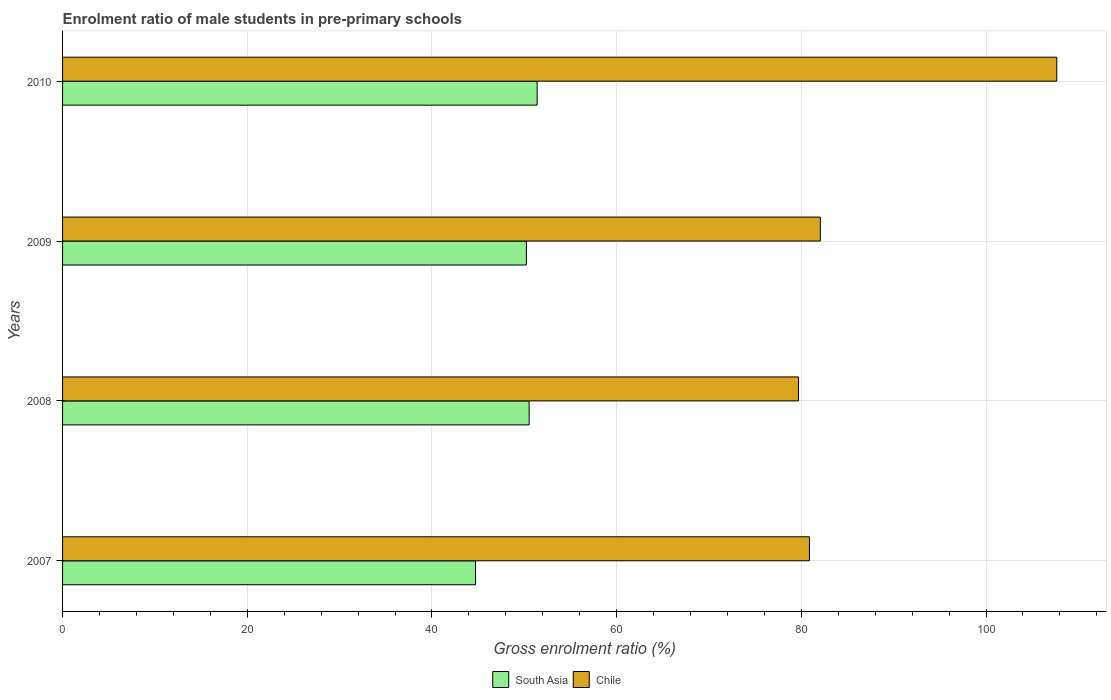How many different coloured bars are there?
Keep it short and to the point. 2. How many groups of bars are there?
Provide a short and direct response. 4. How many bars are there on the 3rd tick from the top?
Provide a short and direct response. 2. How many bars are there on the 2nd tick from the bottom?
Offer a terse response. 2. In how many cases, is the number of bars for a given year not equal to the number of legend labels?
Your answer should be compact. 0. What is the enrolment ratio of male students in pre-primary schools in South Asia in 2010?
Provide a succinct answer. 51.39. Across all years, what is the maximum enrolment ratio of male students in pre-primary schools in South Asia?
Make the answer very short. 51.39. Across all years, what is the minimum enrolment ratio of male students in pre-primary schools in South Asia?
Offer a very short reply. 44.72. In which year was the enrolment ratio of male students in pre-primary schools in South Asia minimum?
Offer a very short reply. 2007. What is the total enrolment ratio of male students in pre-primary schools in South Asia in the graph?
Provide a succinct answer. 196.86. What is the difference between the enrolment ratio of male students in pre-primary schools in South Asia in 2007 and that in 2008?
Your answer should be compact. -5.81. What is the difference between the enrolment ratio of male students in pre-primary schools in Chile in 2010 and the enrolment ratio of male students in pre-primary schools in South Asia in 2007?
Provide a short and direct response. 62.94. What is the average enrolment ratio of male students in pre-primary schools in Chile per year?
Provide a succinct answer. 87.57. In the year 2008, what is the difference between the enrolment ratio of male students in pre-primary schools in South Asia and enrolment ratio of male students in pre-primary schools in Chile?
Make the answer very short. -29.17. In how many years, is the enrolment ratio of male students in pre-primary schools in South Asia greater than 64 %?
Make the answer very short. 0. What is the ratio of the enrolment ratio of male students in pre-primary schools in Chile in 2007 to that in 2008?
Your response must be concise. 1.01. What is the difference between the highest and the second highest enrolment ratio of male students in pre-primary schools in Chile?
Your response must be concise. 25.61. What is the difference between the highest and the lowest enrolment ratio of male students in pre-primary schools in Chile?
Your response must be concise. 27.97. In how many years, is the enrolment ratio of male students in pre-primary schools in Chile greater than the average enrolment ratio of male students in pre-primary schools in Chile taken over all years?
Give a very brief answer. 1. Is the sum of the enrolment ratio of male students in pre-primary schools in South Asia in 2008 and 2010 greater than the maximum enrolment ratio of male students in pre-primary schools in Chile across all years?
Offer a very short reply. No. What does the 1st bar from the top in 2008 represents?
Offer a terse response. Chile. How many bars are there?
Your answer should be very brief. 8. Are all the bars in the graph horizontal?
Offer a very short reply. Yes. How many years are there in the graph?
Your answer should be compact. 4. Are the values on the major ticks of X-axis written in scientific E-notation?
Ensure brevity in your answer.  No. Where does the legend appear in the graph?
Provide a short and direct response. Bottom center. How many legend labels are there?
Your response must be concise. 2. How are the legend labels stacked?
Your answer should be very brief. Horizontal. What is the title of the graph?
Give a very brief answer. Enrolment ratio of male students in pre-primary schools. Does "Slovenia" appear as one of the legend labels in the graph?
Make the answer very short. No. What is the Gross enrolment ratio (%) in South Asia in 2007?
Offer a very short reply. 44.72. What is the Gross enrolment ratio (%) of Chile in 2007?
Provide a succinct answer. 80.88. What is the Gross enrolment ratio (%) in South Asia in 2008?
Provide a succinct answer. 50.52. What is the Gross enrolment ratio (%) of Chile in 2008?
Provide a short and direct response. 79.69. What is the Gross enrolment ratio (%) of South Asia in 2009?
Provide a succinct answer. 50.23. What is the Gross enrolment ratio (%) in Chile in 2009?
Make the answer very short. 82.05. What is the Gross enrolment ratio (%) in South Asia in 2010?
Provide a short and direct response. 51.39. What is the Gross enrolment ratio (%) of Chile in 2010?
Give a very brief answer. 107.66. Across all years, what is the maximum Gross enrolment ratio (%) in South Asia?
Ensure brevity in your answer.  51.39. Across all years, what is the maximum Gross enrolment ratio (%) of Chile?
Provide a succinct answer. 107.66. Across all years, what is the minimum Gross enrolment ratio (%) of South Asia?
Offer a terse response. 44.72. Across all years, what is the minimum Gross enrolment ratio (%) of Chile?
Offer a very short reply. 79.69. What is the total Gross enrolment ratio (%) of South Asia in the graph?
Your answer should be compact. 196.86. What is the total Gross enrolment ratio (%) in Chile in the graph?
Keep it short and to the point. 350.28. What is the difference between the Gross enrolment ratio (%) in South Asia in 2007 and that in 2008?
Provide a short and direct response. -5.81. What is the difference between the Gross enrolment ratio (%) in Chile in 2007 and that in 2008?
Your answer should be compact. 1.19. What is the difference between the Gross enrolment ratio (%) in South Asia in 2007 and that in 2009?
Offer a terse response. -5.51. What is the difference between the Gross enrolment ratio (%) of Chile in 2007 and that in 2009?
Offer a very short reply. -1.18. What is the difference between the Gross enrolment ratio (%) in South Asia in 2007 and that in 2010?
Make the answer very short. -6.67. What is the difference between the Gross enrolment ratio (%) in Chile in 2007 and that in 2010?
Keep it short and to the point. -26.78. What is the difference between the Gross enrolment ratio (%) of South Asia in 2008 and that in 2009?
Provide a short and direct response. 0.3. What is the difference between the Gross enrolment ratio (%) in Chile in 2008 and that in 2009?
Make the answer very short. -2.36. What is the difference between the Gross enrolment ratio (%) of South Asia in 2008 and that in 2010?
Your answer should be very brief. -0.86. What is the difference between the Gross enrolment ratio (%) in Chile in 2008 and that in 2010?
Your answer should be very brief. -27.97. What is the difference between the Gross enrolment ratio (%) of South Asia in 2009 and that in 2010?
Keep it short and to the point. -1.16. What is the difference between the Gross enrolment ratio (%) in Chile in 2009 and that in 2010?
Make the answer very short. -25.61. What is the difference between the Gross enrolment ratio (%) of South Asia in 2007 and the Gross enrolment ratio (%) of Chile in 2008?
Keep it short and to the point. -34.97. What is the difference between the Gross enrolment ratio (%) in South Asia in 2007 and the Gross enrolment ratio (%) in Chile in 2009?
Your answer should be very brief. -37.34. What is the difference between the Gross enrolment ratio (%) of South Asia in 2007 and the Gross enrolment ratio (%) of Chile in 2010?
Give a very brief answer. -62.94. What is the difference between the Gross enrolment ratio (%) in South Asia in 2008 and the Gross enrolment ratio (%) in Chile in 2009?
Keep it short and to the point. -31.53. What is the difference between the Gross enrolment ratio (%) of South Asia in 2008 and the Gross enrolment ratio (%) of Chile in 2010?
Provide a succinct answer. -57.14. What is the difference between the Gross enrolment ratio (%) in South Asia in 2009 and the Gross enrolment ratio (%) in Chile in 2010?
Ensure brevity in your answer.  -57.43. What is the average Gross enrolment ratio (%) of South Asia per year?
Your answer should be compact. 49.21. What is the average Gross enrolment ratio (%) in Chile per year?
Your response must be concise. 87.57. In the year 2007, what is the difference between the Gross enrolment ratio (%) of South Asia and Gross enrolment ratio (%) of Chile?
Offer a very short reply. -36.16. In the year 2008, what is the difference between the Gross enrolment ratio (%) of South Asia and Gross enrolment ratio (%) of Chile?
Offer a terse response. -29.17. In the year 2009, what is the difference between the Gross enrolment ratio (%) in South Asia and Gross enrolment ratio (%) in Chile?
Ensure brevity in your answer.  -31.83. In the year 2010, what is the difference between the Gross enrolment ratio (%) in South Asia and Gross enrolment ratio (%) in Chile?
Your answer should be very brief. -56.27. What is the ratio of the Gross enrolment ratio (%) in South Asia in 2007 to that in 2008?
Ensure brevity in your answer.  0.89. What is the ratio of the Gross enrolment ratio (%) of Chile in 2007 to that in 2008?
Offer a terse response. 1.01. What is the ratio of the Gross enrolment ratio (%) of South Asia in 2007 to that in 2009?
Ensure brevity in your answer.  0.89. What is the ratio of the Gross enrolment ratio (%) of Chile in 2007 to that in 2009?
Offer a very short reply. 0.99. What is the ratio of the Gross enrolment ratio (%) of South Asia in 2007 to that in 2010?
Ensure brevity in your answer.  0.87. What is the ratio of the Gross enrolment ratio (%) in Chile in 2007 to that in 2010?
Provide a short and direct response. 0.75. What is the ratio of the Gross enrolment ratio (%) of South Asia in 2008 to that in 2009?
Your answer should be compact. 1.01. What is the ratio of the Gross enrolment ratio (%) in Chile in 2008 to that in 2009?
Your answer should be compact. 0.97. What is the ratio of the Gross enrolment ratio (%) of South Asia in 2008 to that in 2010?
Provide a short and direct response. 0.98. What is the ratio of the Gross enrolment ratio (%) in Chile in 2008 to that in 2010?
Offer a terse response. 0.74. What is the ratio of the Gross enrolment ratio (%) in South Asia in 2009 to that in 2010?
Your answer should be very brief. 0.98. What is the ratio of the Gross enrolment ratio (%) of Chile in 2009 to that in 2010?
Offer a very short reply. 0.76. What is the difference between the highest and the second highest Gross enrolment ratio (%) of South Asia?
Offer a very short reply. 0.86. What is the difference between the highest and the second highest Gross enrolment ratio (%) in Chile?
Your response must be concise. 25.61. What is the difference between the highest and the lowest Gross enrolment ratio (%) in South Asia?
Offer a terse response. 6.67. What is the difference between the highest and the lowest Gross enrolment ratio (%) in Chile?
Give a very brief answer. 27.97. 